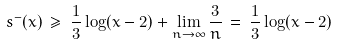Convert formula to latex. <formula><loc_0><loc_0><loc_500><loc_500>s ^ { - } ( x ) \, \geq \, \frac { 1 } { 3 } \log ( x - 2 ) + \lim _ { n \rightarrow \infty } \frac { 3 } { n } \, = \, \frac { 1 } { 3 } \log ( x - 2 )</formula> 